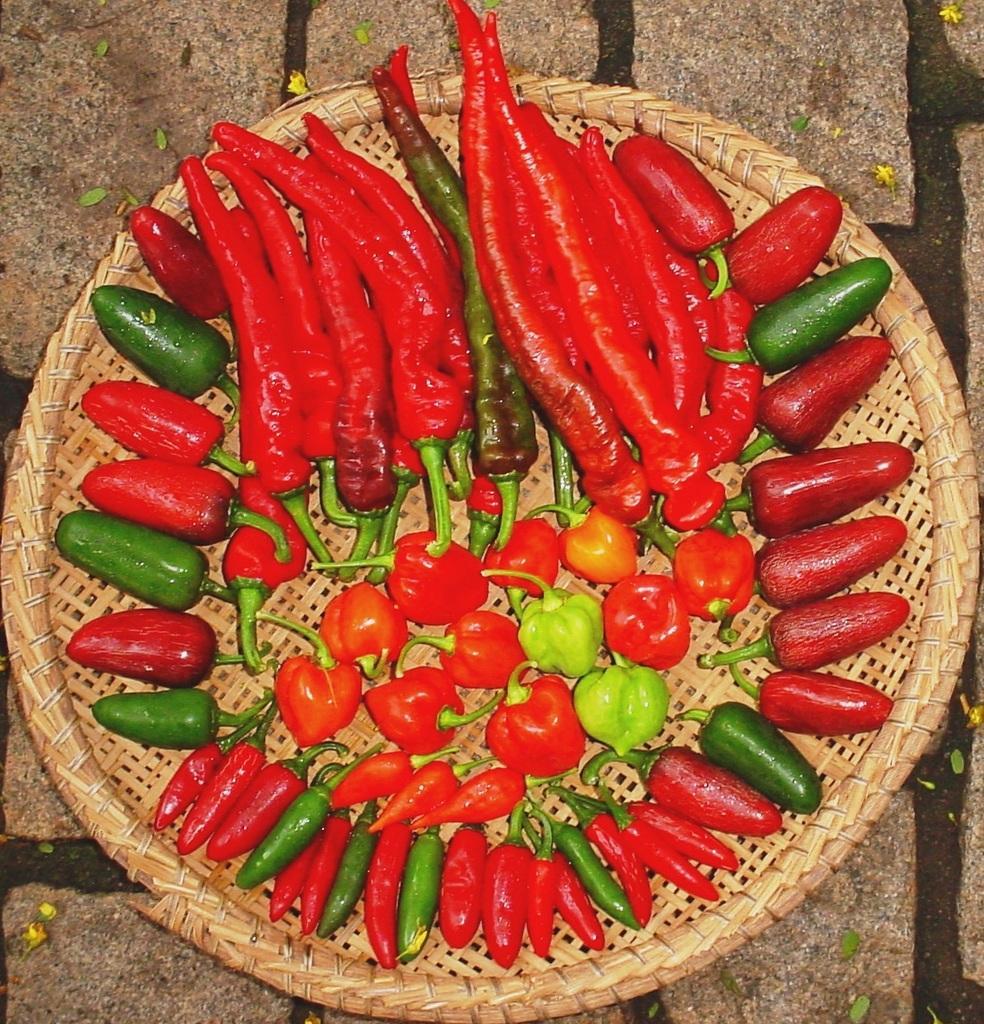Can you describe this image briefly? This is the wooden plate, which is placed on the ground. This plate contains red and green chilies, cherry tomatoes, jalapeno on the plate. 